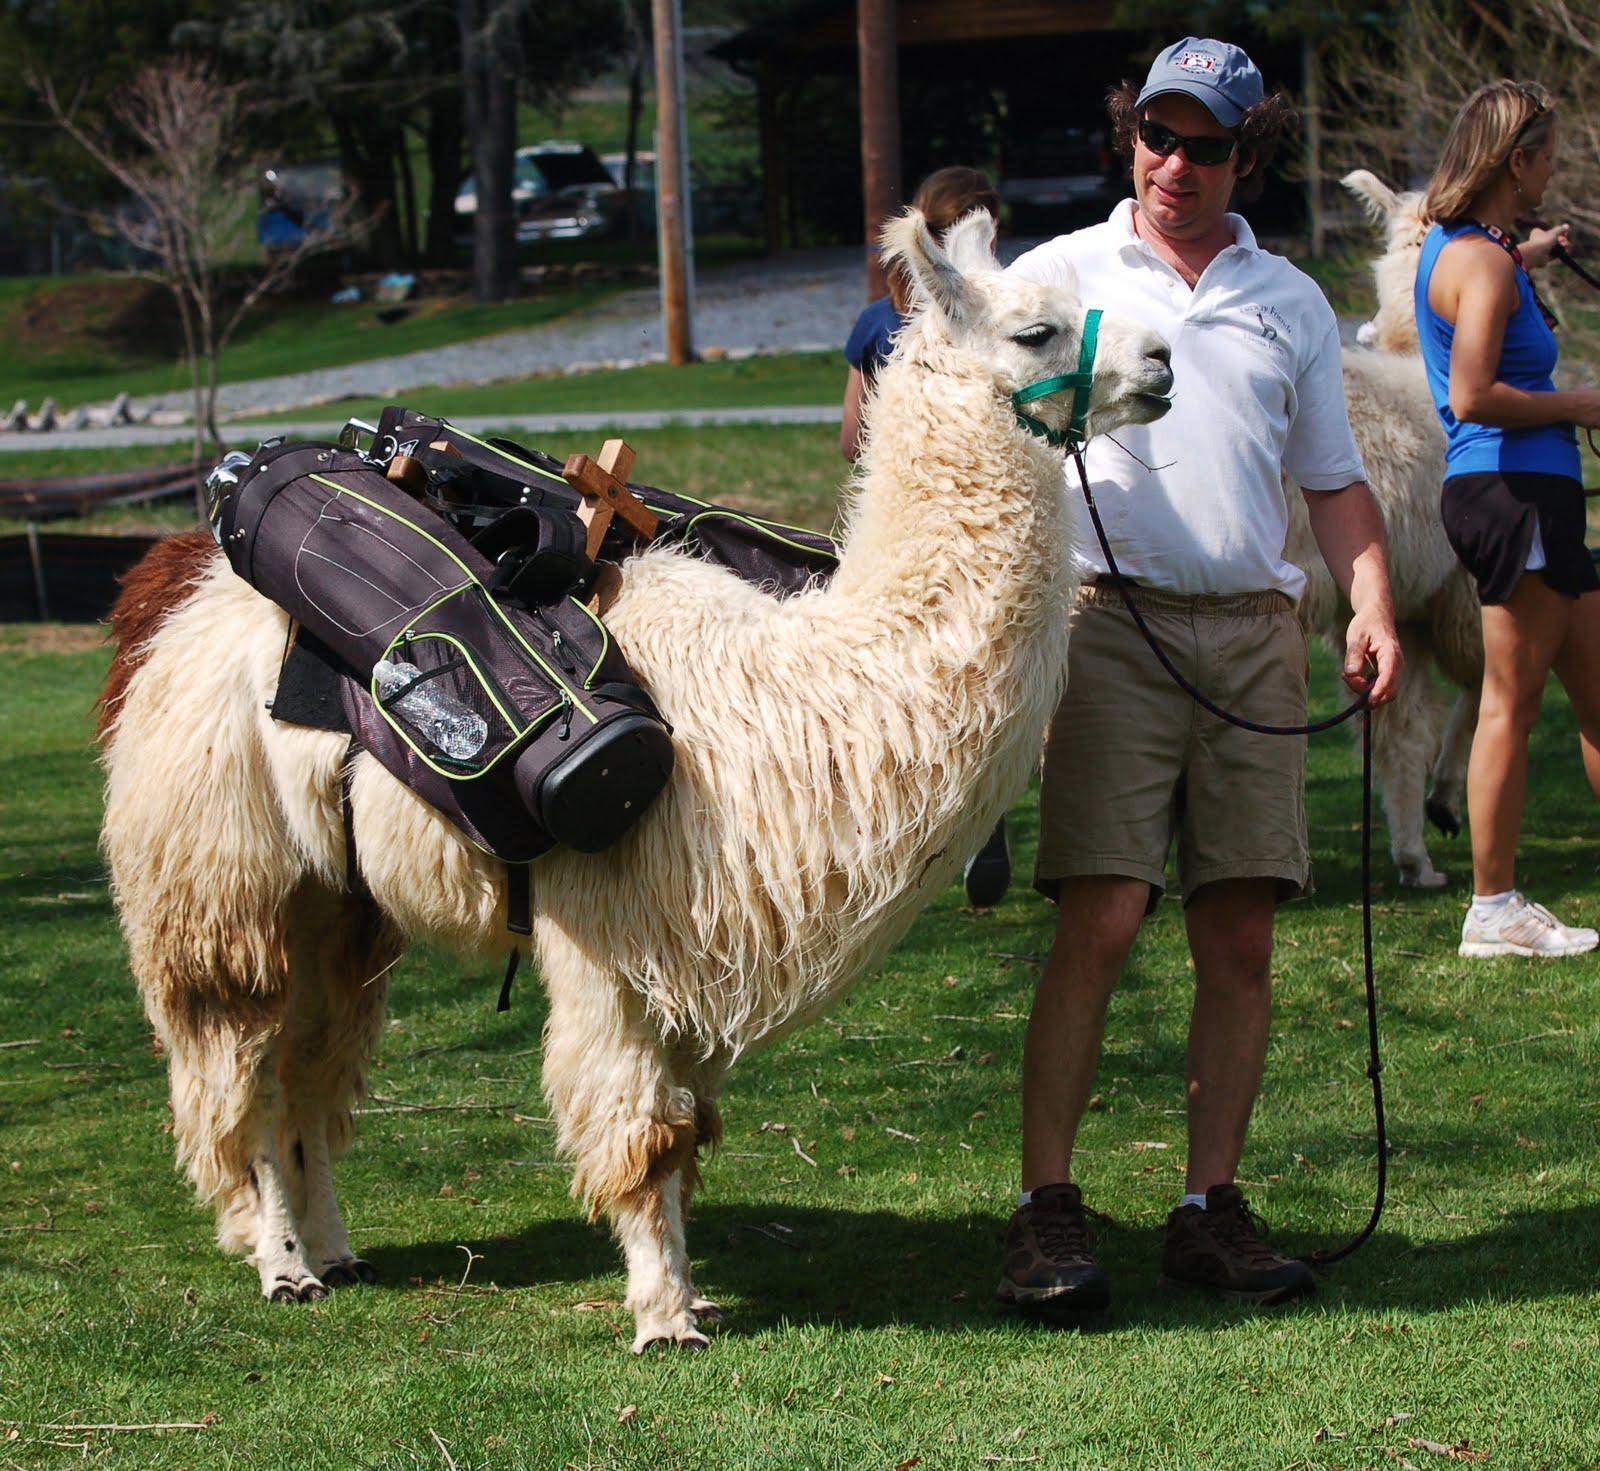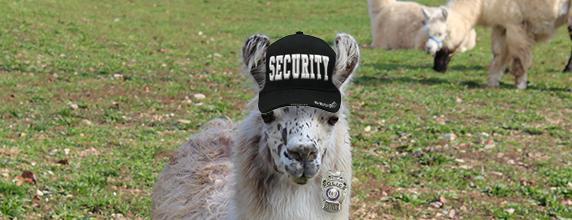The first image is the image on the left, the second image is the image on the right. Given the left and right images, does the statement "The left image shows a man in shorts and sunglasses standing by a white llama wearing a pack, and the right image shows a forward-turned llama wearing some type of attire." hold true? Answer yes or no. Yes. 